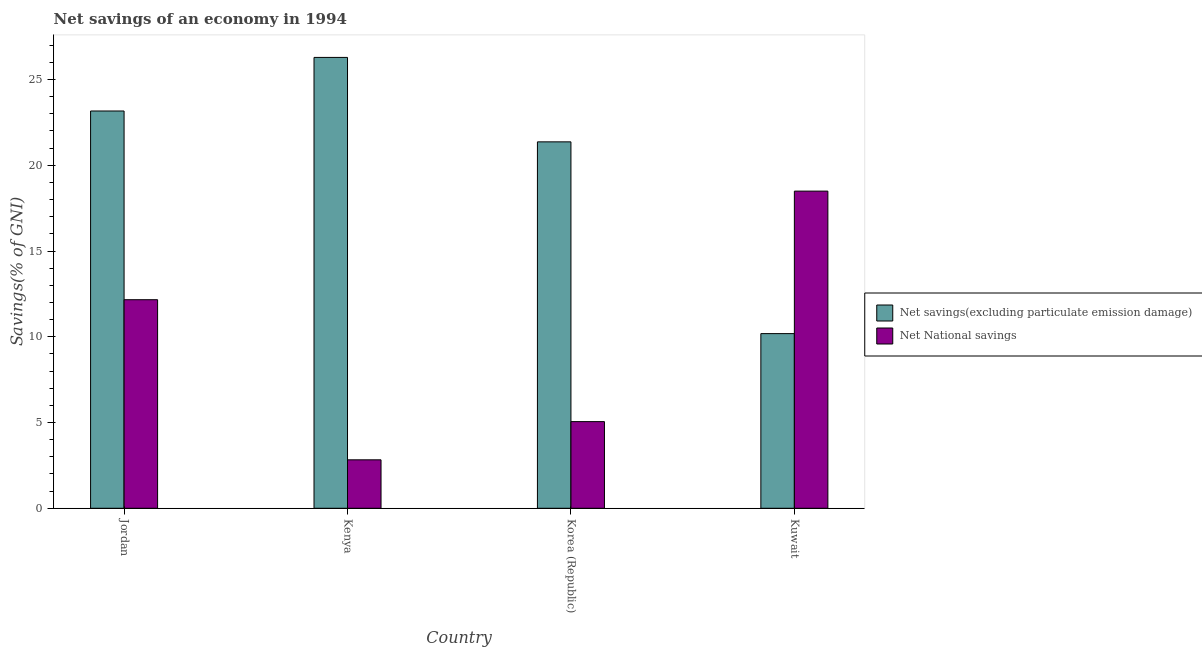Are the number of bars per tick equal to the number of legend labels?
Provide a succinct answer. Yes. What is the label of the 4th group of bars from the left?
Your answer should be very brief. Kuwait. In how many cases, is the number of bars for a given country not equal to the number of legend labels?
Ensure brevity in your answer.  0. What is the net savings(excluding particulate emission damage) in Kuwait?
Give a very brief answer. 10.18. Across all countries, what is the maximum net savings(excluding particulate emission damage)?
Your response must be concise. 26.29. Across all countries, what is the minimum net savings(excluding particulate emission damage)?
Give a very brief answer. 10.18. In which country was the net national savings maximum?
Provide a short and direct response. Kuwait. In which country was the net national savings minimum?
Provide a short and direct response. Kenya. What is the total net savings(excluding particulate emission damage) in the graph?
Give a very brief answer. 81. What is the difference between the net savings(excluding particulate emission damage) in Kenya and that in Kuwait?
Your answer should be compact. 16.1. What is the difference between the net national savings in Korea (Republic) and the net savings(excluding particulate emission damage) in Kuwait?
Your response must be concise. -5.13. What is the average net national savings per country?
Provide a succinct answer. 9.63. What is the difference between the net savings(excluding particulate emission damage) and net national savings in Kuwait?
Offer a very short reply. -8.31. In how many countries, is the net national savings greater than 14 %?
Your response must be concise. 1. What is the ratio of the net national savings in Jordan to that in Kuwait?
Offer a terse response. 0.66. Is the net national savings in Kenya less than that in Kuwait?
Ensure brevity in your answer.  Yes. Is the difference between the net savings(excluding particulate emission damage) in Jordan and Korea (Republic) greater than the difference between the net national savings in Jordan and Korea (Republic)?
Ensure brevity in your answer.  No. What is the difference between the highest and the second highest net national savings?
Provide a succinct answer. 6.33. What is the difference between the highest and the lowest net savings(excluding particulate emission damage)?
Offer a very short reply. 16.1. Is the sum of the net savings(excluding particulate emission damage) in Jordan and Korea (Republic) greater than the maximum net national savings across all countries?
Your response must be concise. Yes. What does the 2nd bar from the left in Kuwait represents?
Offer a terse response. Net National savings. What does the 1st bar from the right in Korea (Republic) represents?
Ensure brevity in your answer.  Net National savings. How many bars are there?
Offer a terse response. 8. Are all the bars in the graph horizontal?
Your response must be concise. No. How many countries are there in the graph?
Keep it short and to the point. 4. What is the difference between two consecutive major ticks on the Y-axis?
Provide a short and direct response. 5. Are the values on the major ticks of Y-axis written in scientific E-notation?
Ensure brevity in your answer.  No. Does the graph contain grids?
Offer a very short reply. No. How many legend labels are there?
Your answer should be very brief. 2. What is the title of the graph?
Offer a terse response. Net savings of an economy in 1994. Does "Chemicals" appear as one of the legend labels in the graph?
Provide a short and direct response. No. What is the label or title of the X-axis?
Provide a succinct answer. Country. What is the label or title of the Y-axis?
Your response must be concise. Savings(% of GNI). What is the Savings(% of GNI) of Net savings(excluding particulate emission damage) in Jordan?
Provide a succinct answer. 23.16. What is the Savings(% of GNI) in Net National savings in Jordan?
Provide a short and direct response. 12.16. What is the Savings(% of GNI) in Net savings(excluding particulate emission damage) in Kenya?
Provide a succinct answer. 26.29. What is the Savings(% of GNI) in Net National savings in Kenya?
Make the answer very short. 2.82. What is the Savings(% of GNI) of Net savings(excluding particulate emission damage) in Korea (Republic)?
Your response must be concise. 21.36. What is the Savings(% of GNI) in Net National savings in Korea (Republic)?
Your answer should be compact. 5.05. What is the Savings(% of GNI) of Net savings(excluding particulate emission damage) in Kuwait?
Your response must be concise. 10.18. What is the Savings(% of GNI) of Net National savings in Kuwait?
Offer a terse response. 18.49. Across all countries, what is the maximum Savings(% of GNI) in Net savings(excluding particulate emission damage)?
Give a very brief answer. 26.29. Across all countries, what is the maximum Savings(% of GNI) of Net National savings?
Make the answer very short. 18.49. Across all countries, what is the minimum Savings(% of GNI) in Net savings(excluding particulate emission damage)?
Make the answer very short. 10.18. Across all countries, what is the minimum Savings(% of GNI) of Net National savings?
Offer a very short reply. 2.82. What is the total Savings(% of GNI) in Net savings(excluding particulate emission damage) in the graph?
Give a very brief answer. 81. What is the total Savings(% of GNI) in Net National savings in the graph?
Provide a succinct answer. 38.53. What is the difference between the Savings(% of GNI) of Net savings(excluding particulate emission damage) in Jordan and that in Kenya?
Give a very brief answer. -3.12. What is the difference between the Savings(% of GNI) of Net National savings in Jordan and that in Kenya?
Offer a very short reply. 9.34. What is the difference between the Savings(% of GNI) in Net savings(excluding particulate emission damage) in Jordan and that in Korea (Republic)?
Ensure brevity in your answer.  1.8. What is the difference between the Savings(% of GNI) in Net National savings in Jordan and that in Korea (Republic)?
Offer a very short reply. 7.11. What is the difference between the Savings(% of GNI) in Net savings(excluding particulate emission damage) in Jordan and that in Kuwait?
Keep it short and to the point. 12.98. What is the difference between the Savings(% of GNI) of Net National savings in Jordan and that in Kuwait?
Your answer should be very brief. -6.33. What is the difference between the Savings(% of GNI) in Net savings(excluding particulate emission damage) in Kenya and that in Korea (Republic)?
Provide a short and direct response. 4.92. What is the difference between the Savings(% of GNI) in Net National savings in Kenya and that in Korea (Republic)?
Your answer should be very brief. -2.23. What is the difference between the Savings(% of GNI) in Net savings(excluding particulate emission damage) in Kenya and that in Kuwait?
Your answer should be very brief. 16.1. What is the difference between the Savings(% of GNI) of Net National savings in Kenya and that in Kuwait?
Ensure brevity in your answer.  -15.67. What is the difference between the Savings(% of GNI) in Net savings(excluding particulate emission damage) in Korea (Republic) and that in Kuwait?
Give a very brief answer. 11.18. What is the difference between the Savings(% of GNI) in Net National savings in Korea (Republic) and that in Kuwait?
Make the answer very short. -13.44. What is the difference between the Savings(% of GNI) in Net savings(excluding particulate emission damage) in Jordan and the Savings(% of GNI) in Net National savings in Kenya?
Provide a short and direct response. 20.34. What is the difference between the Savings(% of GNI) in Net savings(excluding particulate emission damage) in Jordan and the Savings(% of GNI) in Net National savings in Korea (Republic)?
Your answer should be very brief. 18.11. What is the difference between the Savings(% of GNI) of Net savings(excluding particulate emission damage) in Jordan and the Savings(% of GNI) of Net National savings in Kuwait?
Provide a short and direct response. 4.67. What is the difference between the Savings(% of GNI) of Net savings(excluding particulate emission damage) in Kenya and the Savings(% of GNI) of Net National savings in Korea (Republic)?
Your answer should be very brief. 21.24. What is the difference between the Savings(% of GNI) in Net savings(excluding particulate emission damage) in Kenya and the Savings(% of GNI) in Net National savings in Kuwait?
Provide a short and direct response. 7.8. What is the difference between the Savings(% of GNI) in Net savings(excluding particulate emission damage) in Korea (Republic) and the Savings(% of GNI) in Net National savings in Kuwait?
Keep it short and to the point. 2.87. What is the average Savings(% of GNI) in Net savings(excluding particulate emission damage) per country?
Ensure brevity in your answer.  20.25. What is the average Savings(% of GNI) in Net National savings per country?
Your answer should be very brief. 9.63. What is the difference between the Savings(% of GNI) in Net savings(excluding particulate emission damage) and Savings(% of GNI) in Net National savings in Jordan?
Provide a short and direct response. 11. What is the difference between the Savings(% of GNI) in Net savings(excluding particulate emission damage) and Savings(% of GNI) in Net National savings in Kenya?
Make the answer very short. 23.46. What is the difference between the Savings(% of GNI) of Net savings(excluding particulate emission damage) and Savings(% of GNI) of Net National savings in Korea (Republic)?
Give a very brief answer. 16.31. What is the difference between the Savings(% of GNI) of Net savings(excluding particulate emission damage) and Savings(% of GNI) of Net National savings in Kuwait?
Your answer should be compact. -8.31. What is the ratio of the Savings(% of GNI) in Net savings(excluding particulate emission damage) in Jordan to that in Kenya?
Offer a terse response. 0.88. What is the ratio of the Savings(% of GNI) in Net National savings in Jordan to that in Kenya?
Offer a very short reply. 4.31. What is the ratio of the Savings(% of GNI) in Net savings(excluding particulate emission damage) in Jordan to that in Korea (Republic)?
Ensure brevity in your answer.  1.08. What is the ratio of the Savings(% of GNI) in Net National savings in Jordan to that in Korea (Republic)?
Offer a very short reply. 2.41. What is the ratio of the Savings(% of GNI) of Net savings(excluding particulate emission damage) in Jordan to that in Kuwait?
Provide a short and direct response. 2.27. What is the ratio of the Savings(% of GNI) in Net National savings in Jordan to that in Kuwait?
Provide a short and direct response. 0.66. What is the ratio of the Savings(% of GNI) of Net savings(excluding particulate emission damage) in Kenya to that in Korea (Republic)?
Provide a short and direct response. 1.23. What is the ratio of the Savings(% of GNI) of Net National savings in Kenya to that in Korea (Republic)?
Make the answer very short. 0.56. What is the ratio of the Savings(% of GNI) in Net savings(excluding particulate emission damage) in Kenya to that in Kuwait?
Offer a terse response. 2.58. What is the ratio of the Savings(% of GNI) of Net National savings in Kenya to that in Kuwait?
Your answer should be very brief. 0.15. What is the ratio of the Savings(% of GNI) in Net savings(excluding particulate emission damage) in Korea (Republic) to that in Kuwait?
Your answer should be very brief. 2.1. What is the ratio of the Savings(% of GNI) of Net National savings in Korea (Republic) to that in Kuwait?
Provide a short and direct response. 0.27. What is the difference between the highest and the second highest Savings(% of GNI) in Net savings(excluding particulate emission damage)?
Your answer should be compact. 3.12. What is the difference between the highest and the second highest Savings(% of GNI) of Net National savings?
Give a very brief answer. 6.33. What is the difference between the highest and the lowest Savings(% of GNI) in Net savings(excluding particulate emission damage)?
Keep it short and to the point. 16.1. What is the difference between the highest and the lowest Savings(% of GNI) in Net National savings?
Provide a short and direct response. 15.67. 